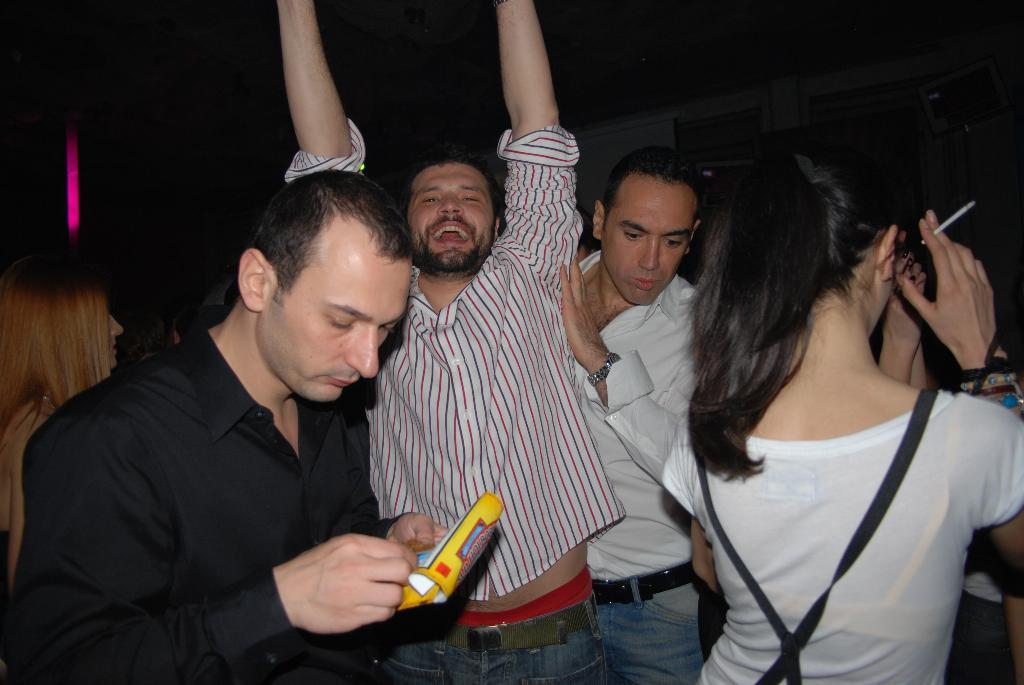Who is present in the image? There are people in the image. Can you describe the expression of one of the individuals? A man is smiling in the image. What else can be seen in the image besides the people? There are objects in the image. How would you describe the lighting in the image? The background of the image is dark. What is the suggestion made by the girls in the image? There are no girls present in the image, so no suggestion can be attributed to them. 